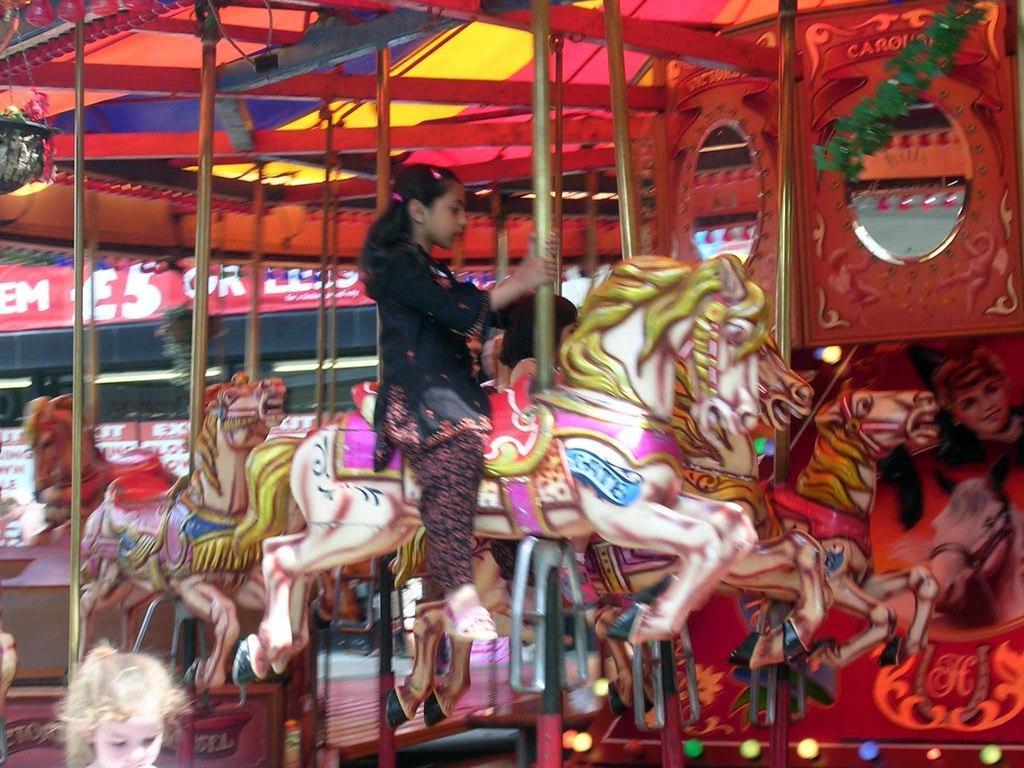Could you give a brief overview of what you see in this image? This image is clicked in exhibition where a girl is sitting on a horse. It is a ride. She is wearing black color dress. 